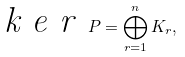Convert formula to latex. <formula><loc_0><loc_0><loc_500><loc_500>\emph { k e r } \, P = \bigoplus _ { r = 1 } ^ { n } K _ { r } ,</formula> 